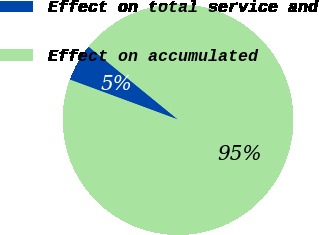Convert chart. <chart><loc_0><loc_0><loc_500><loc_500><pie_chart><fcel>Effect on total service and<fcel>Effect on accumulated<nl><fcel>5.26%<fcel>94.74%<nl></chart> 